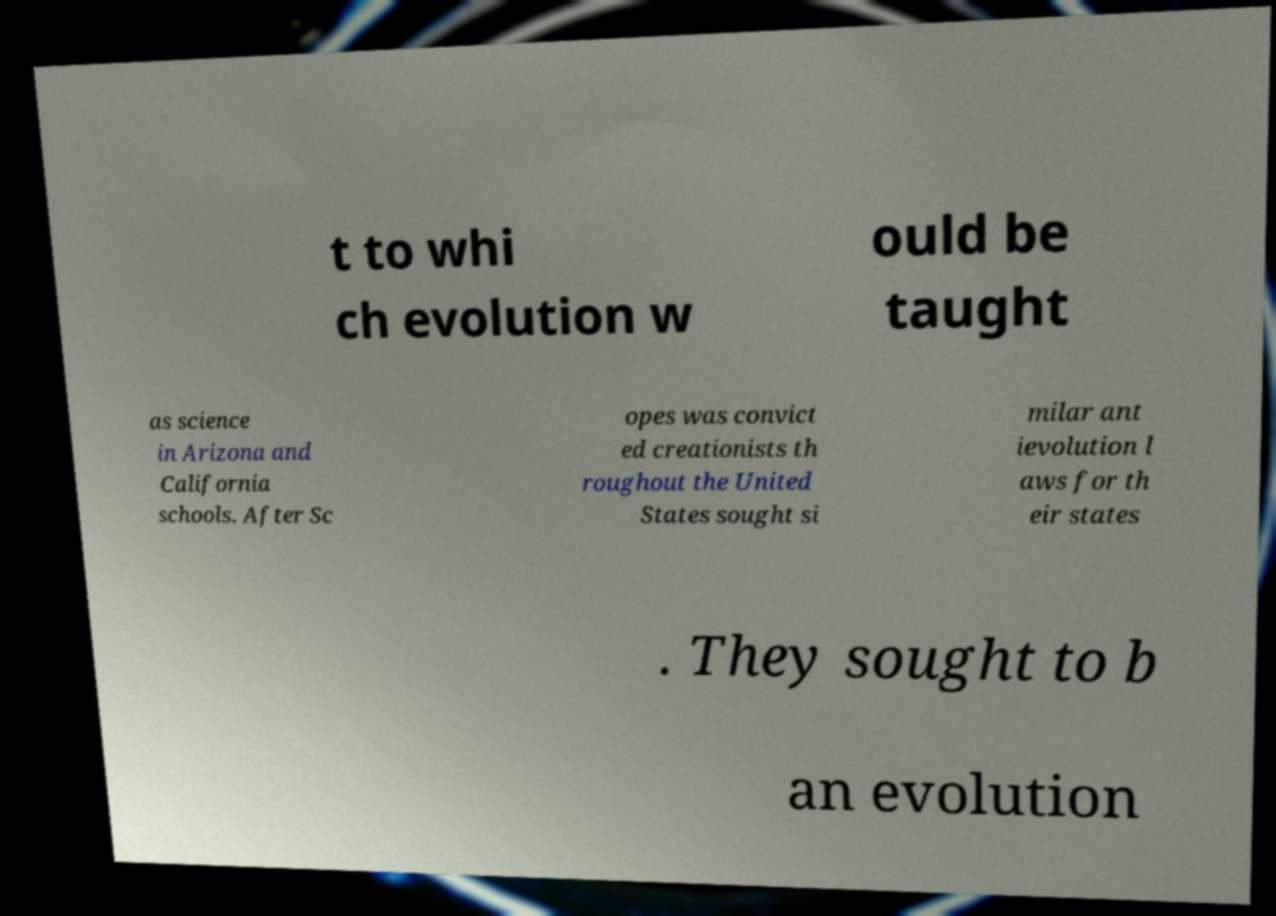What messages or text are displayed in this image? I need them in a readable, typed format. t to whi ch evolution w ould be taught as science in Arizona and California schools. After Sc opes was convict ed creationists th roughout the United States sought si milar ant ievolution l aws for th eir states . They sought to b an evolution 